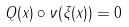<formula> <loc_0><loc_0><loc_500><loc_500>Q ( x ) \circ \nu ( \xi ( x ) ) = 0</formula> 